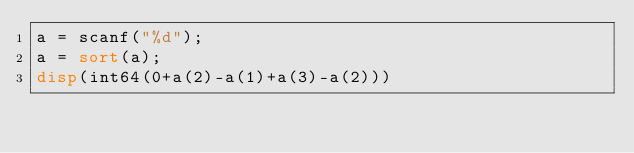Convert code to text. <code><loc_0><loc_0><loc_500><loc_500><_Octave_>a = scanf("%d");
a = sort(a);
disp(int64(0+a(2)-a(1)+a(3)-a(2)))</code> 